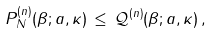<formula> <loc_0><loc_0><loc_500><loc_500>P ^ { ( n ) } _ { N } ( \beta ; a , \kappa ) \, \leq \, \mathcal { Q } ^ { ( n ) } ( \beta ; a , \kappa ) \, ,</formula> 